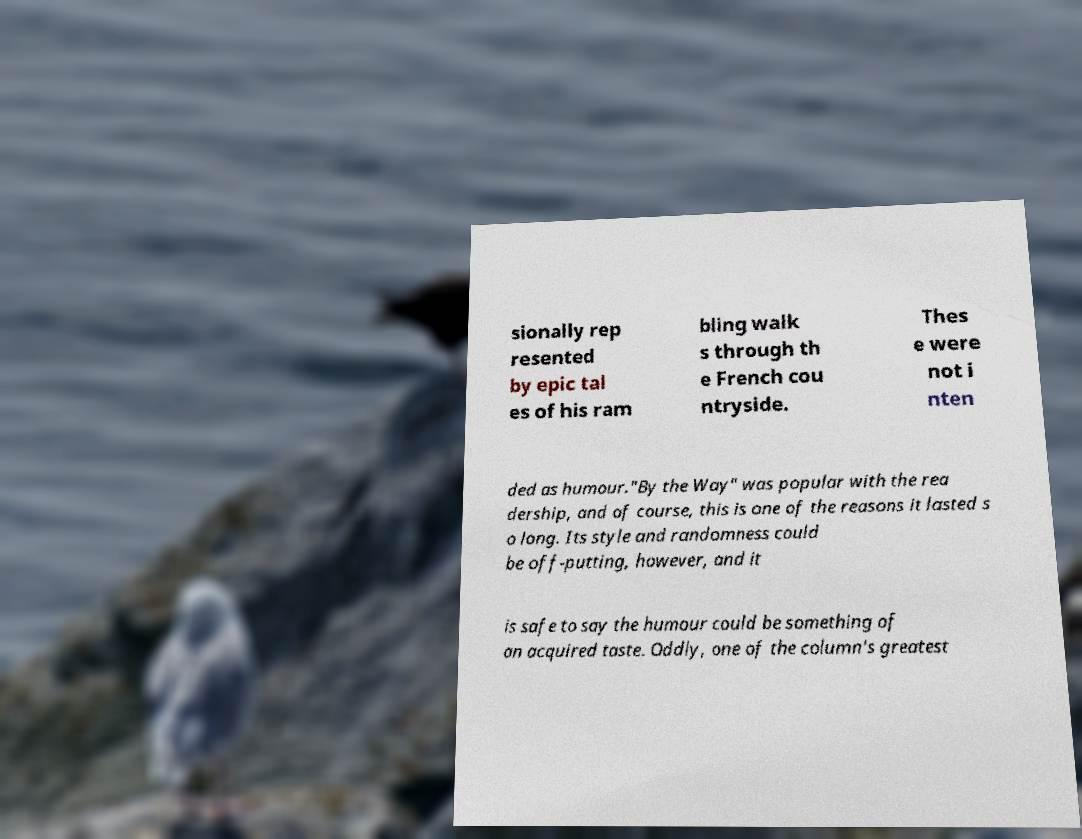Please identify and transcribe the text found in this image. sionally rep resented by epic tal es of his ram bling walk s through th e French cou ntryside. Thes e were not i nten ded as humour."By the Way" was popular with the rea dership, and of course, this is one of the reasons it lasted s o long. Its style and randomness could be off-putting, however, and it is safe to say the humour could be something of an acquired taste. Oddly, one of the column's greatest 